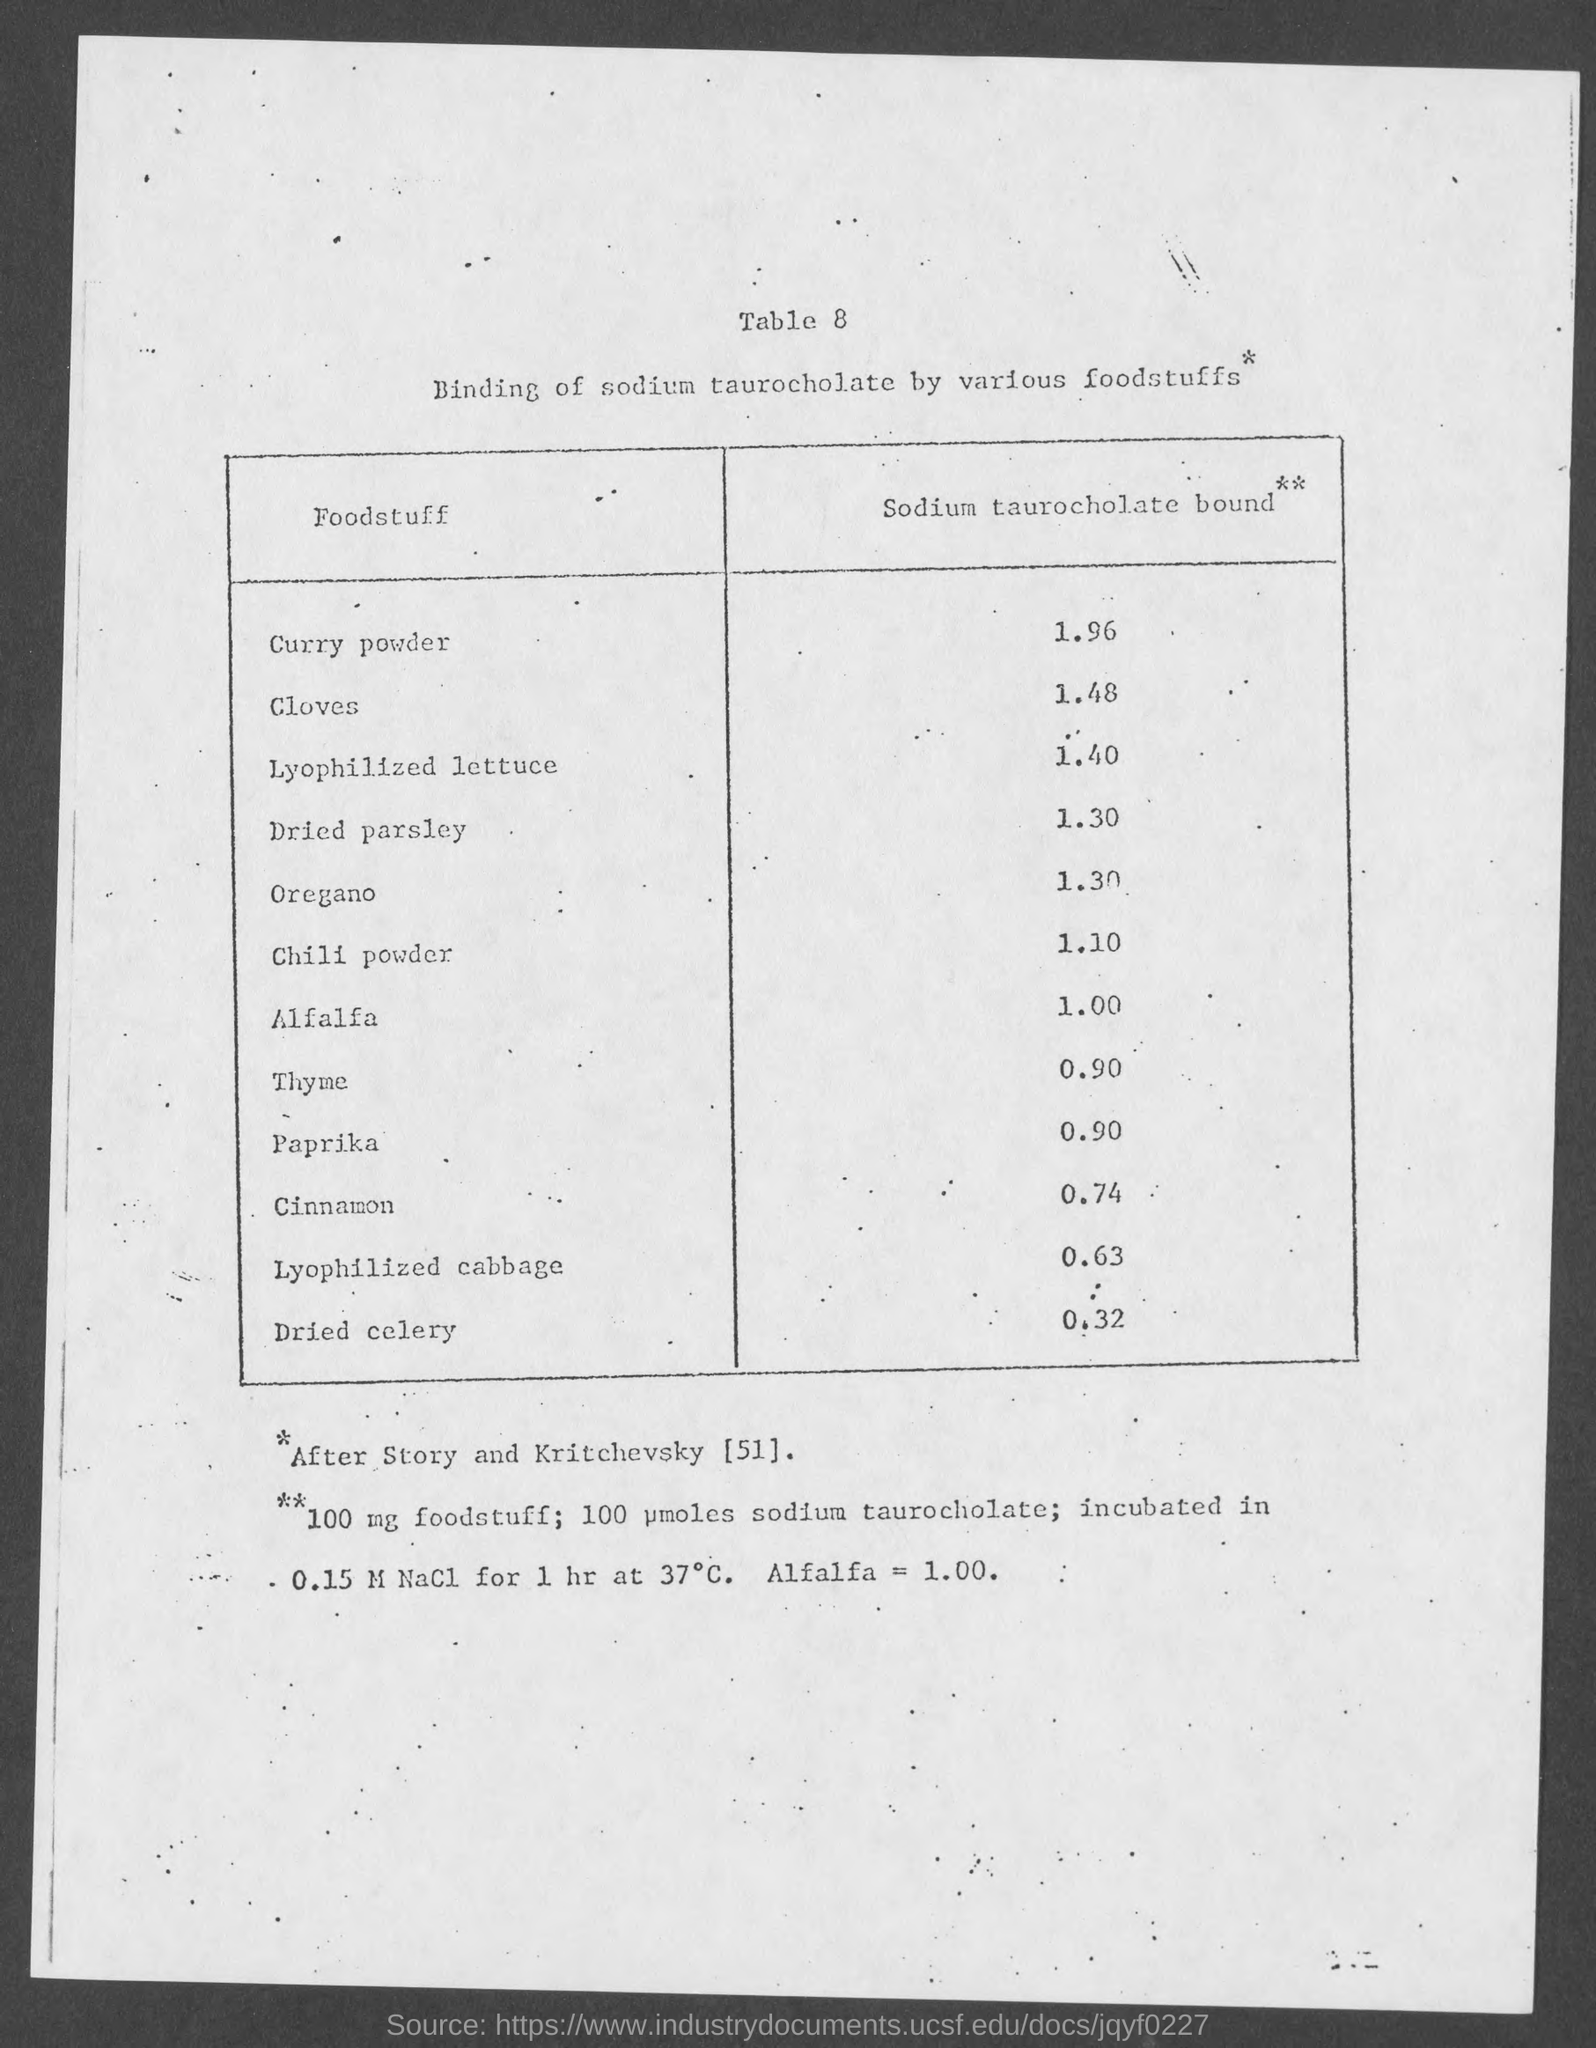Highlight a few significant elements in this photo. Alfalfa has a value of 1.00 Sodium taurocholate bound, which is a type of foodstuff. The value of Sodium taurocholate bound in cloves is 1.48. 